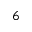<formula> <loc_0><loc_0><loc_500><loc_500>^ { 6 }</formula> 